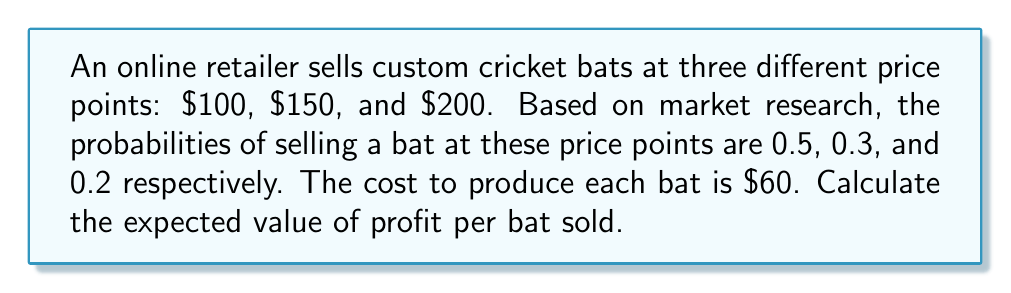What is the answer to this math problem? To solve this problem, we'll follow these steps:

1) First, let's calculate the profit for each price point:
   
   For $100 bat: Profit = $100 - $60 = $40
   For $150 bat: Profit = $150 - $60 = $90
   For $200 bat: Profit = $200 - $60 = $140

2) Now, we'll use the expected value formula:

   $$ E(X) = \sum_{i=1}^n x_i \cdot p(x_i) $$

   Where $x_i$ is the profit for each scenario and $p(x_i)$ is the probability of that scenario.

3) Let's plug in our values:

   $$ E(\text{Profit}) = 40 \cdot 0.5 + 90 \cdot 0.3 + 140 \cdot 0.2 $$

4) Now we calculate:

   $$ E(\text{Profit}) = 20 + 27 + 28 = 75 $$

Therefore, the expected value of profit per bat sold is $75.
Answer: $75 